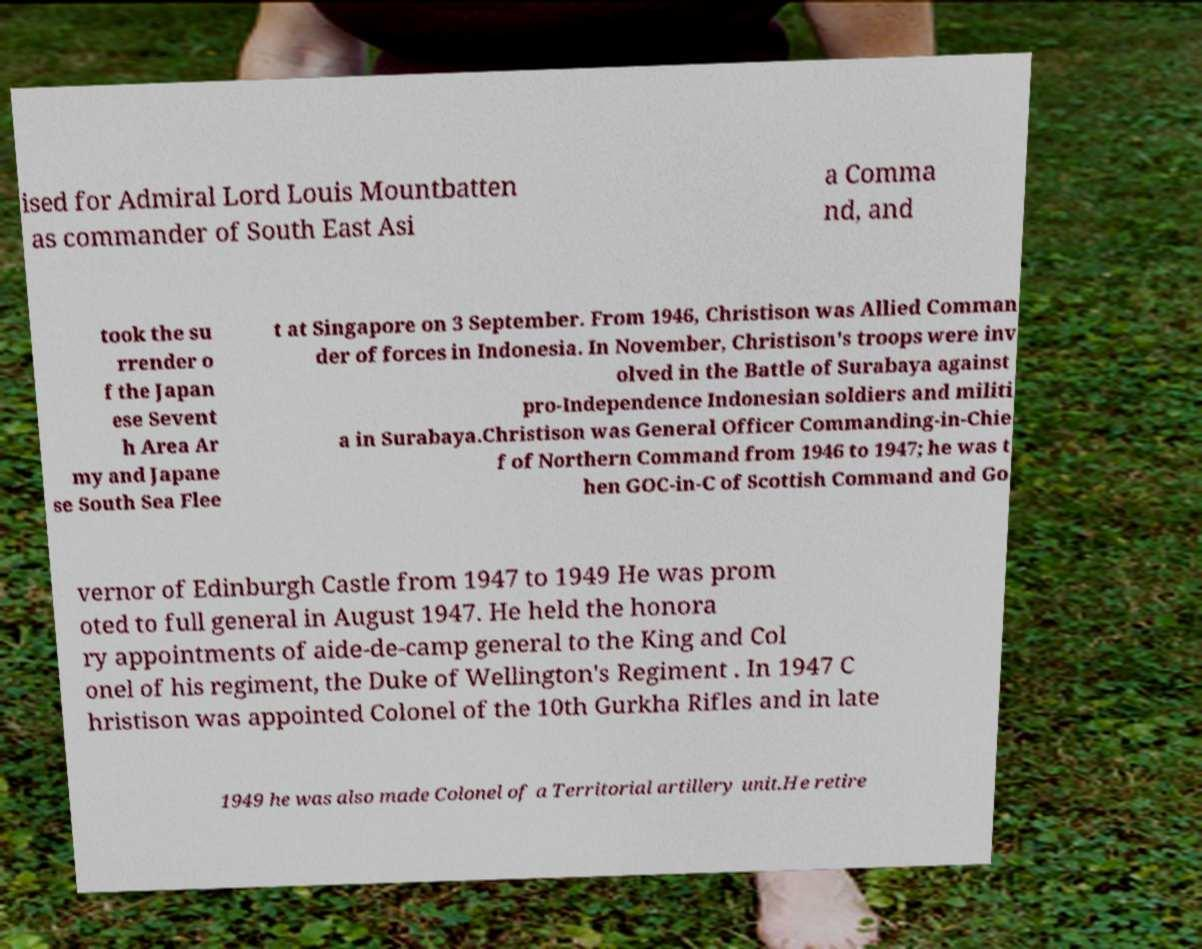For documentation purposes, I need the text within this image transcribed. Could you provide that? ised for Admiral Lord Louis Mountbatten as commander of South East Asi a Comma nd, and took the su rrender o f the Japan ese Sevent h Area Ar my and Japane se South Sea Flee t at Singapore on 3 September. From 1946, Christison was Allied Comman der of forces in Indonesia. In November, Christison's troops were inv olved in the Battle of Surabaya against pro-Independence Indonesian soldiers and militi a in Surabaya.Christison was General Officer Commanding-in-Chie f of Northern Command from 1946 to 1947; he was t hen GOC-in-C of Scottish Command and Go vernor of Edinburgh Castle from 1947 to 1949 He was prom oted to full general in August 1947. He held the honora ry appointments of aide-de-camp general to the King and Col onel of his regiment, the Duke of Wellington's Regiment . In 1947 C hristison was appointed Colonel of the 10th Gurkha Rifles and in late 1949 he was also made Colonel of a Territorial artillery unit.He retire 